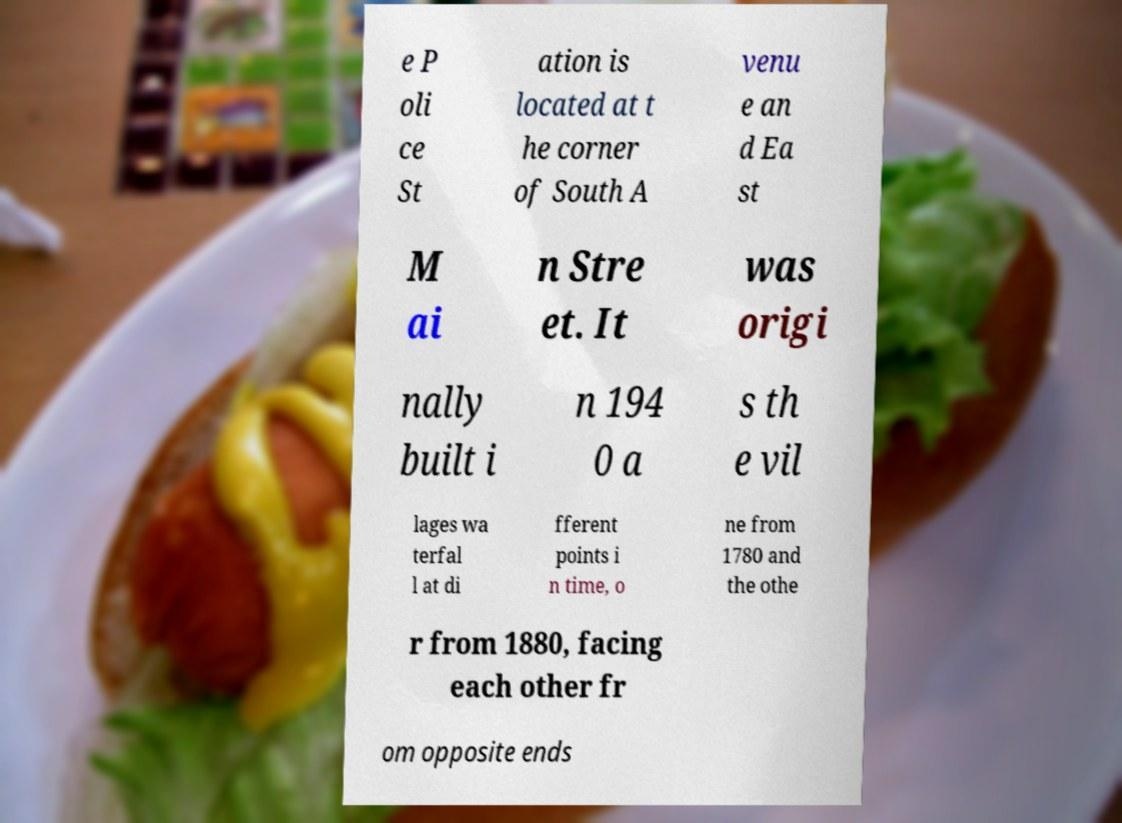Can you accurately transcribe the text from the provided image for me? e P oli ce St ation is located at t he corner of South A venu e an d Ea st M ai n Stre et. It was origi nally built i n 194 0 a s th e vil lages wa terfal l at di fferent points i n time, o ne from 1780 and the othe r from 1880, facing each other fr om opposite ends 